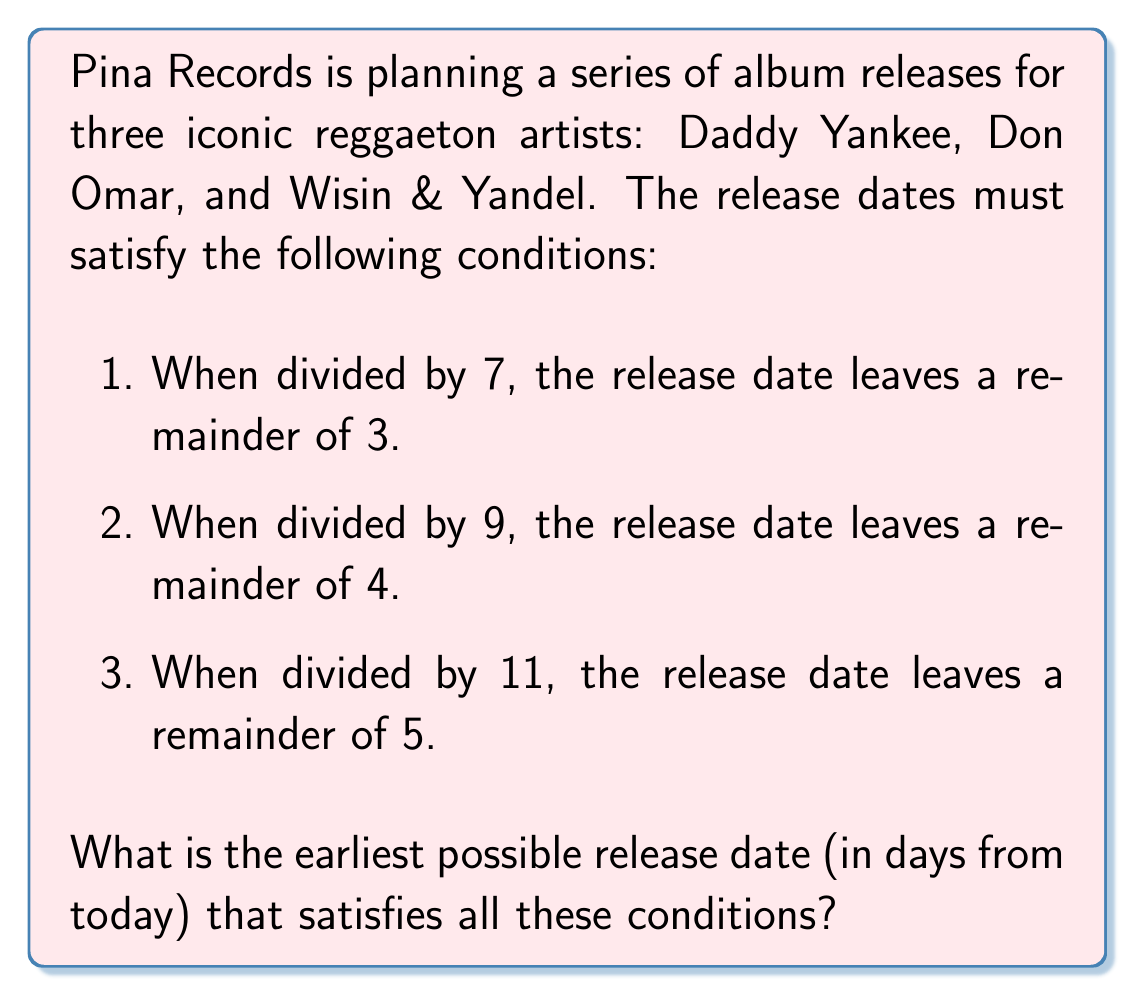Show me your answer to this math problem. Let's solve this using the Chinese Remainder Theorem (CRT). We have the following system of congruences:

$$x \equiv 3 \pmod{7}$$
$$x \equiv 4 \pmod{9}$$
$$x \equiv 5 \pmod{11}$$

Step 1: Calculate $N = 7 \times 9 \times 11 = 693$

Step 2: Calculate $N_i$ for each congruence:
$N_1 = N/7 = 99$
$N_2 = N/9 = 77$
$N_3 = N/11 = 63$

Step 3: Find the modular multiplicative inverses:
$99^{-1} \equiv 1 \pmod{7}$
$77^{-1} \equiv 5 \pmod{9}$
$63^{-1} \equiv 8 \pmod{11}$

Step 4: Calculate the solution:
$$x = (3 \times 99 \times 1 + 4 \times 77 \times 5 + 5 \times 63 \times 8) \pmod{693}$$
$$x = (297 + 1540 + 2520) \pmod{693}$$
$$x = 4357 \pmod{693}$$
$$x = 158$$

Therefore, the earliest possible release date that satisfies all conditions is 158 days from today.
Answer: 158 days 